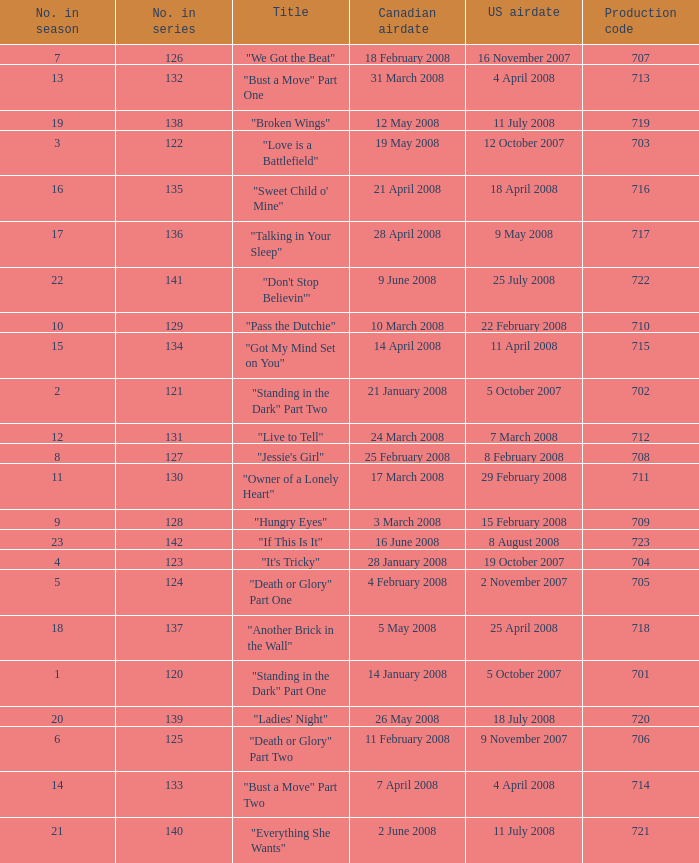For the episode(s) aired in the U.S. on 4 april 2008, what were the names? "Bust a Move" Part One, "Bust a Move" Part Two. 